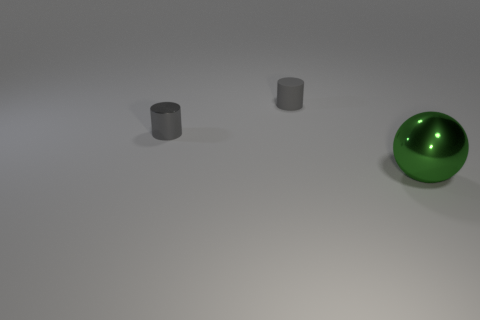What materials do the objects appear to be made from? The green object appears to be made of a shiny, reflective metal with a smooth finish, indicative of a polished surface. The two grey cylinders seem to have a matte finish and could be made of metal or a type of plastic. 